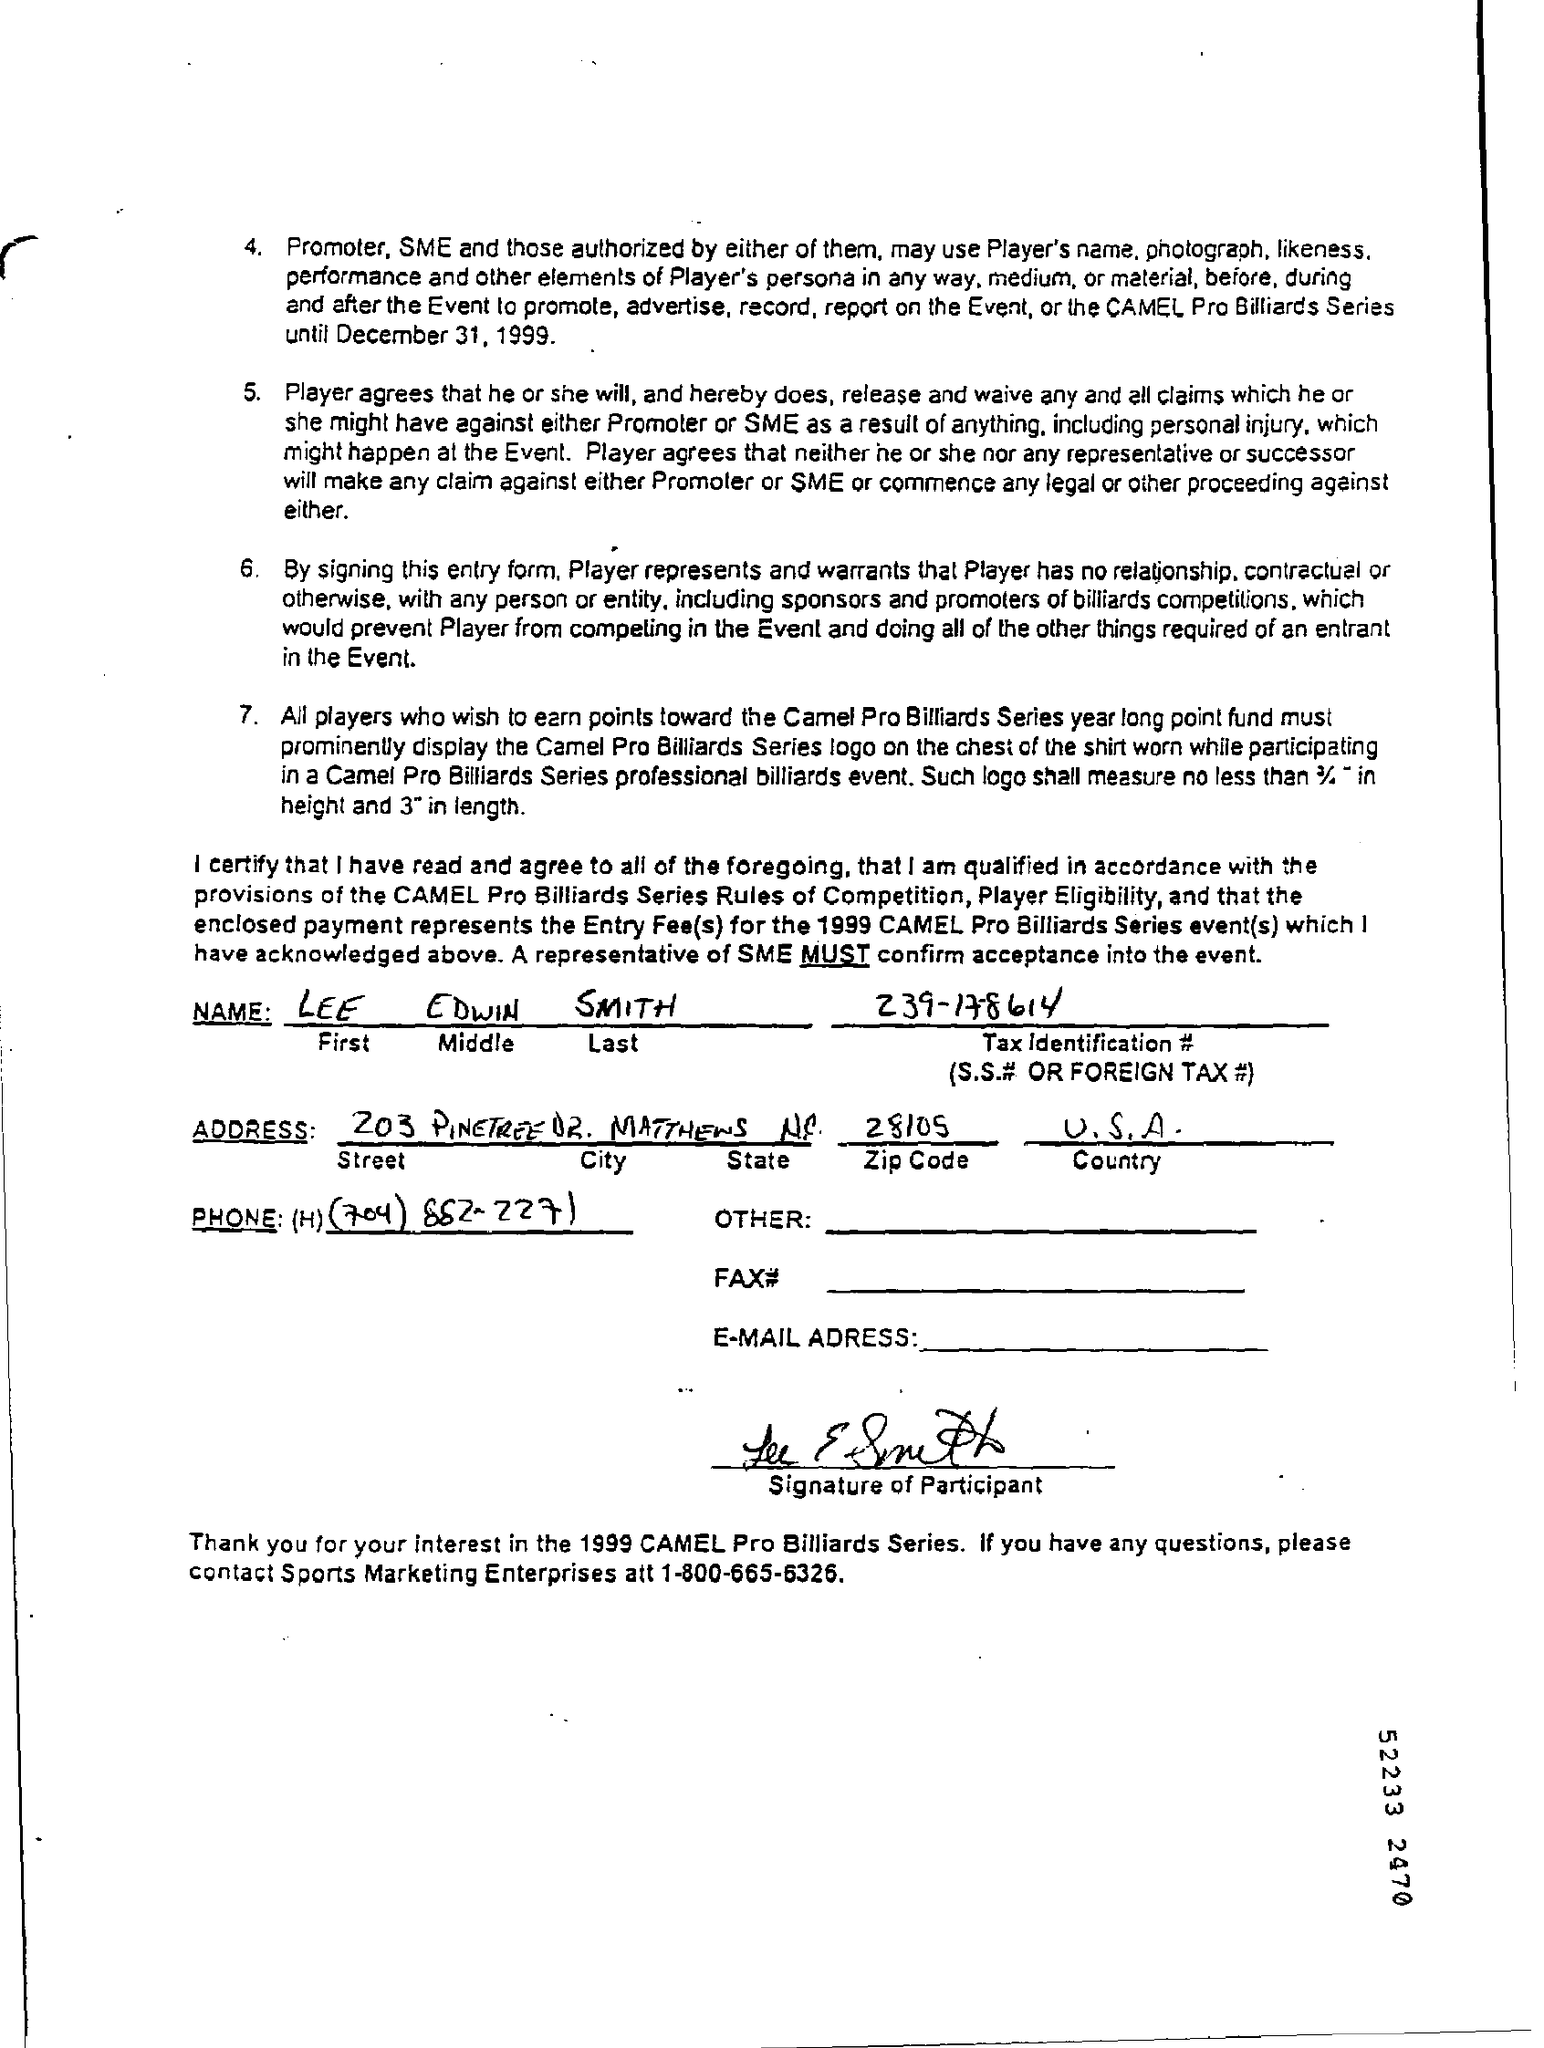Point out several critical features in this image. The name mentioned is Lee Edwin Smith. The phone number of Sports Marketing Enterprises is 1-800-665-6326. The taxpayer's tax identification number is either their social security number or foreign tax identification number, specifically 239-17-8614. The country to which the United States of America belongs is the United States of America. The zip code is 28105. 